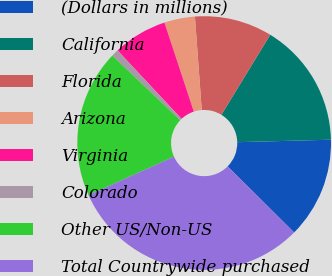<chart> <loc_0><loc_0><loc_500><loc_500><pie_chart><fcel>(Dollars in millions)<fcel>California<fcel>Florida<fcel>Arizona<fcel>Virginia<fcel>Colorado<fcel>Other US/Non-US<fcel>Total Countrywide purchased<nl><fcel>12.87%<fcel>15.86%<fcel>9.88%<fcel>3.91%<fcel>6.9%<fcel>0.92%<fcel>18.85%<fcel>30.81%<nl></chart> 